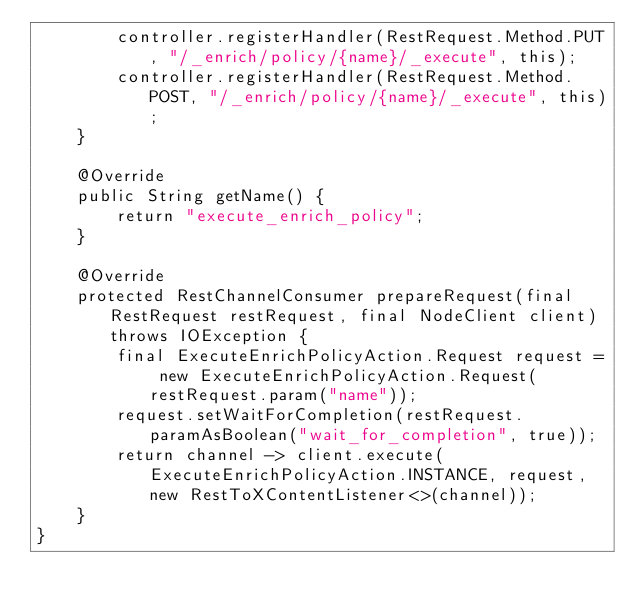<code> <loc_0><loc_0><loc_500><loc_500><_Java_>        controller.registerHandler(RestRequest.Method.PUT, "/_enrich/policy/{name}/_execute", this);
        controller.registerHandler(RestRequest.Method.POST, "/_enrich/policy/{name}/_execute", this);
    }

    @Override
    public String getName() {
        return "execute_enrich_policy";
    }

    @Override
    protected RestChannelConsumer prepareRequest(final RestRequest restRequest, final NodeClient client) throws IOException {
        final ExecuteEnrichPolicyAction.Request request = new ExecuteEnrichPolicyAction.Request(restRequest.param("name"));
        request.setWaitForCompletion(restRequest.paramAsBoolean("wait_for_completion", true));
        return channel -> client.execute(ExecuteEnrichPolicyAction.INSTANCE, request, new RestToXContentListener<>(channel));
    }
}
</code> 